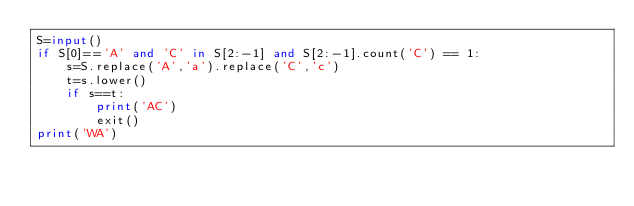<code> <loc_0><loc_0><loc_500><loc_500><_Python_>S=input()
if S[0]=='A' and 'C' in S[2:-1] and S[2:-1].count('C') == 1:
    s=S.replace('A','a').replace('C','c')
    t=s.lower()
    if s==t:
        print('AC')
        exit()
print('WA')</code> 